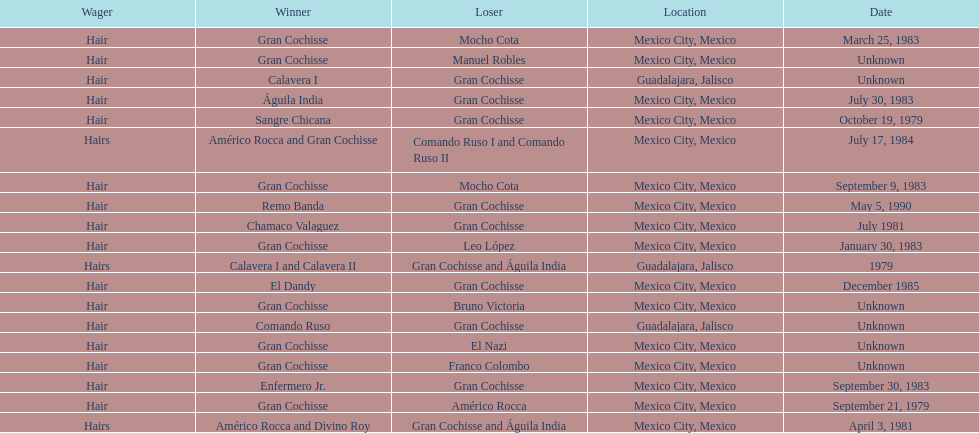How many winners were there before bruno victoria lost? 3. 